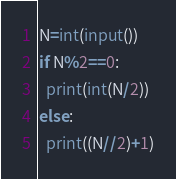Convert code to text. <code><loc_0><loc_0><loc_500><loc_500><_Python_>N=int(input())
if N%2==0:
  print(int(N/2))
else:
  print((N//2)+1)</code> 